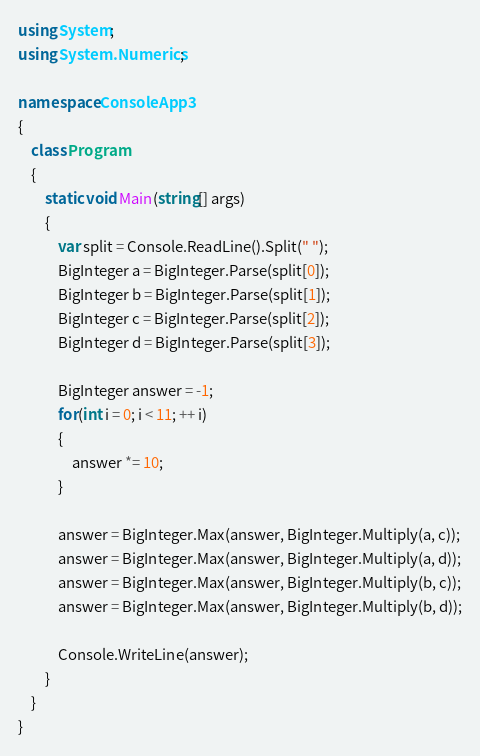<code> <loc_0><loc_0><loc_500><loc_500><_C#_>using System;
using System.Numerics;

namespace ConsoleApp3
{
    class Program
    {
        static void Main(string[] args)
        {
            var split = Console.ReadLine().Split(" ");
            BigInteger a = BigInteger.Parse(split[0]);
            BigInteger b = BigInteger.Parse(split[1]);
            BigInteger c = BigInteger.Parse(split[2]);
            BigInteger d = BigInteger.Parse(split[3]);

            BigInteger answer = -1;
            for(int i = 0; i < 11; ++ i)
            {
                answer *= 10;
            }

            answer = BigInteger.Max(answer, BigInteger.Multiply(a, c));
            answer = BigInteger.Max(answer, BigInteger.Multiply(a, d));
            answer = BigInteger.Max(answer, BigInteger.Multiply(b, c));
            answer = BigInteger.Max(answer, BigInteger.Multiply(b, d));

            Console.WriteLine(answer);
        }
    }
}
</code> 